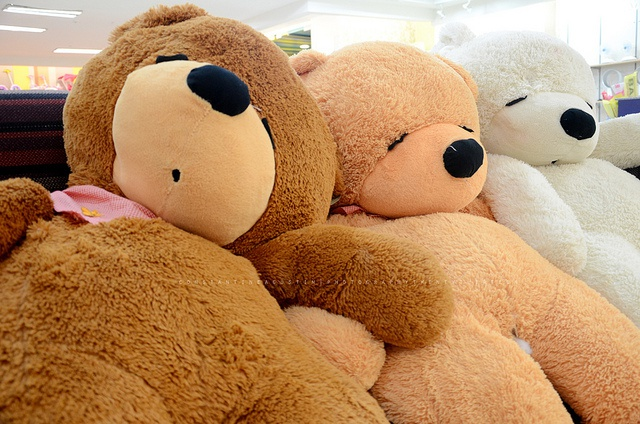Describe the objects in this image and their specific colors. I can see teddy bear in darkgray, brown, tan, and maroon tones, teddy bear in darkgray, tan, and brown tones, and teddy bear in darkgray, lightgray, and tan tones in this image. 